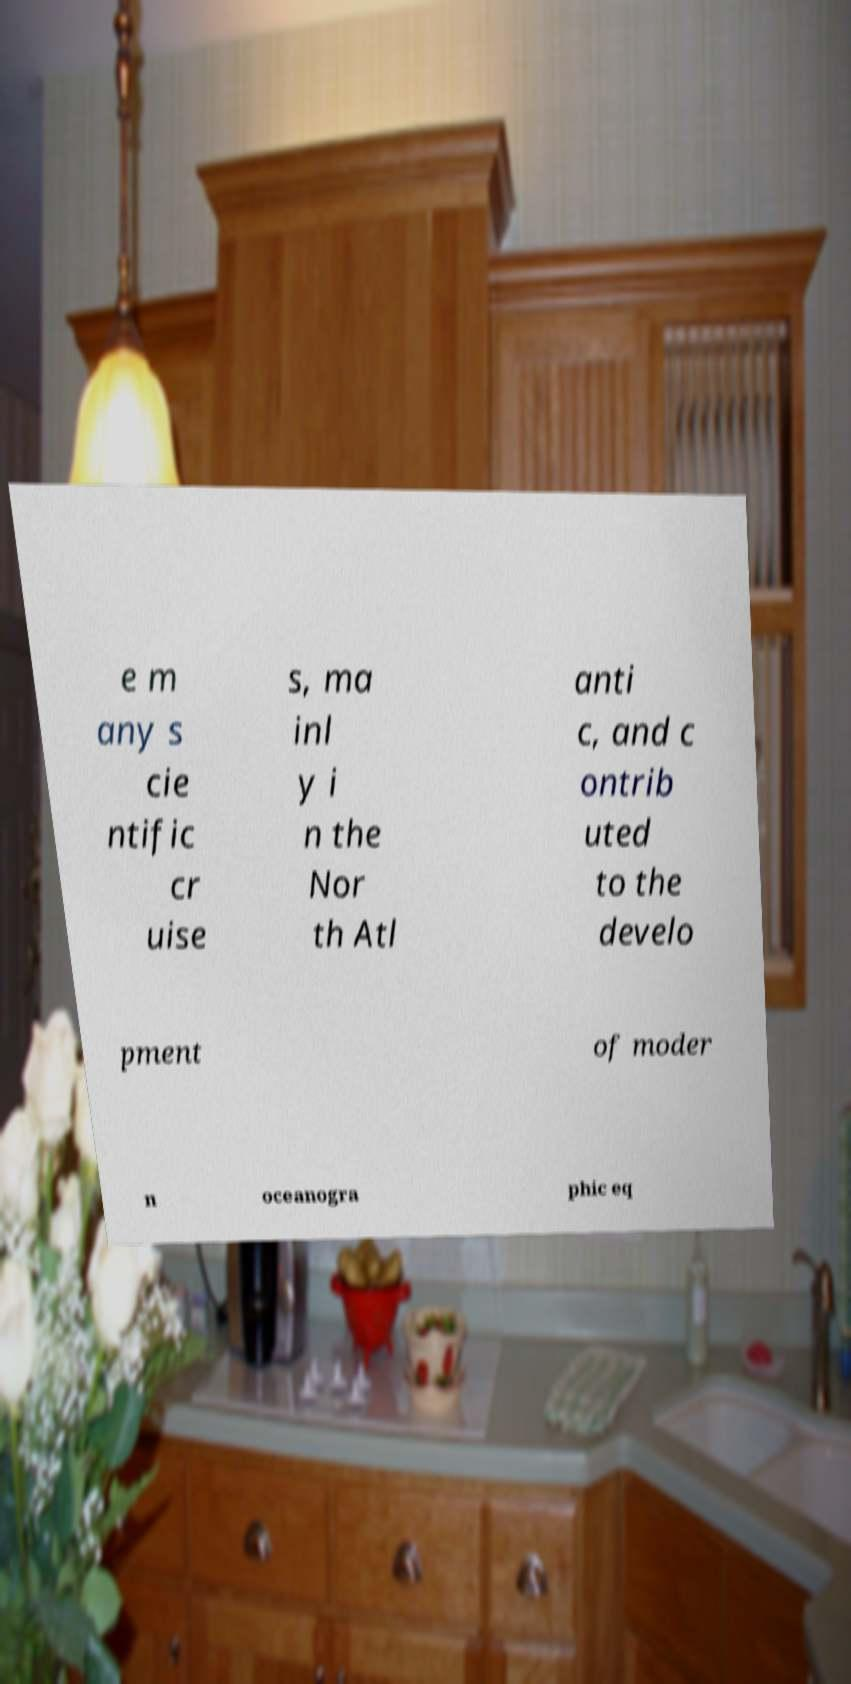For documentation purposes, I need the text within this image transcribed. Could you provide that? e m any s cie ntific cr uise s, ma inl y i n the Nor th Atl anti c, and c ontrib uted to the develo pment of moder n oceanogra phic eq 